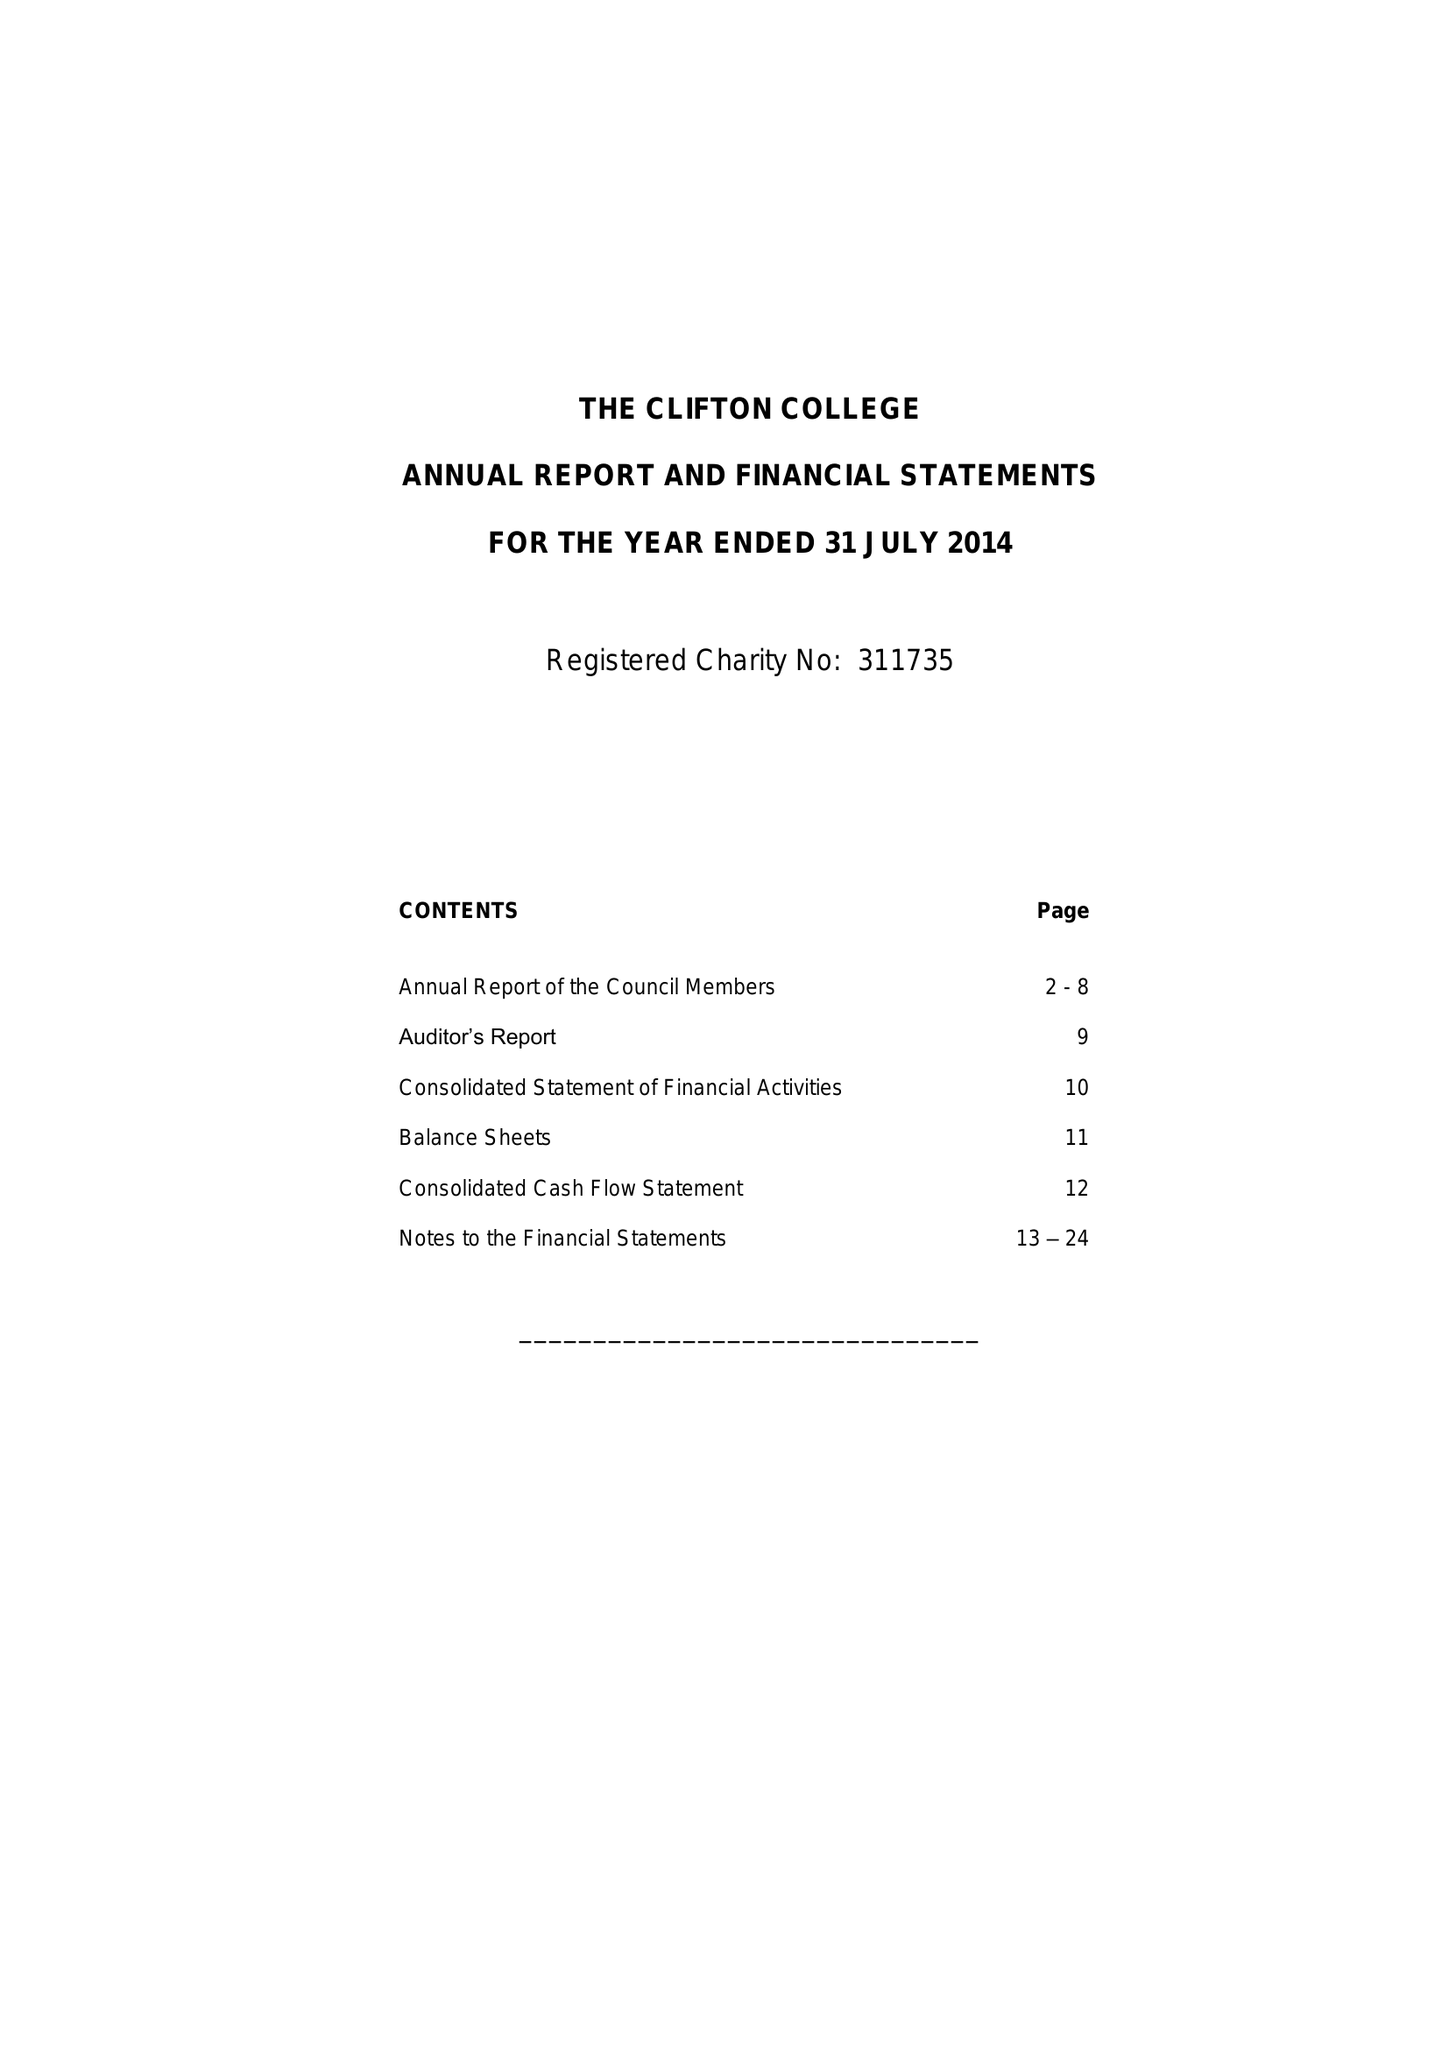What is the value for the address__post_town?
Answer the question using a single word or phrase. BRISTOL 